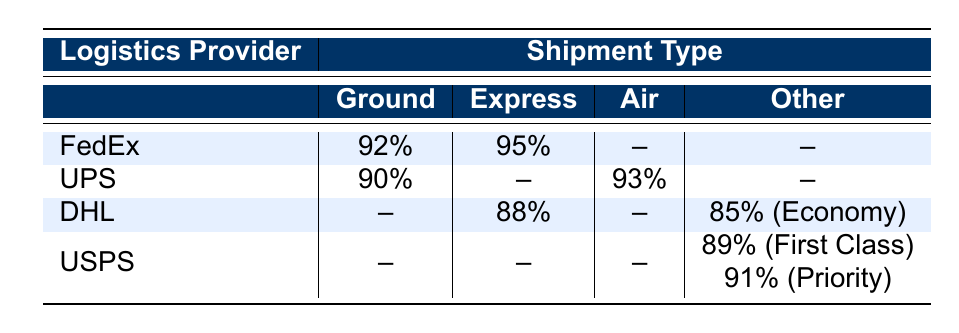What is the on-time delivery rate for FedEx's Express shipment type? The table shows that the on-time delivery rate for FedEx's Express shipment type is 95%.
Answer: 95% Which logistics provider has the highest on-time delivery rate for Ground shipments? According to the table, FedEx has the highest on-time delivery rate for Ground shipments at 92%.
Answer: FedEx What is the on-time delivery rate for DHL's Economy shipment type? The table indicates that the on-time delivery rate for DHL's Economy shipment type is 85%.
Answer: 85% Is the on-time delivery rate for UPS's Air shipment type greater than that for USPS's Priority shipment type? The on-time delivery rate for UPS's Air shipment type is 93%, while that for USPS's Priority shipment type is 91%. Since 93% is greater than 91%, the answer is yes.
Answer: Yes What is the average on-time delivery rate for the Express shipment type across all providers? To find the average, add the on-time delivery rates for Express (95% + 88%) and divide by the number of providers with Express rates (2): (95 + 88) / 2 = 91.5%.
Answer: 91.5% Which logistics provider has lower on-time delivery rates for both their Express and Air shipment types? The table shows that DHL has an on-time delivery rate of 88% for Express, and UPS has a lower on-time delivery rate for Air at 93%, suggesting that DHL performs worse in Express, making the answer DHL.
Answer: DHL Which shipment type has the least on-time delivery rate among the listed shipment types? From the table, DHL's Economy shipment type has the least on-time delivery rate of 85%, as all other listed delivery rates are higher.
Answer: Economy Is there any logistics provider that does not have an Express shipment type listed? Yes, the logistics provider USPS does not have an Express shipment type listed in the table, as it only lists First Class and Priority.
Answer: Yes What percentage difference exists between FedEx's Ground and UPS's Ground on-time delivery rates? FedEx's Ground is at 92% and UPS's Ground is at 90%. The percentage difference is calculated as (92 - 90) = 2%.
Answer: 2% 